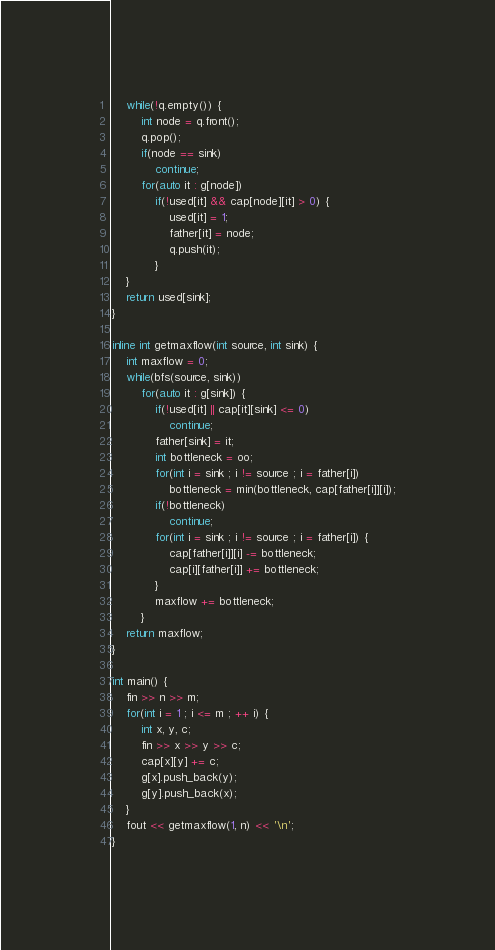Convert code to text. <code><loc_0><loc_0><loc_500><loc_500><_C++_>	while(!q.empty()) {
		int node = q.front();
		q.pop();
		if(node == sink)
			continue;
		for(auto it : g[node])
			if(!used[it] && cap[node][it] > 0) {
				used[it] = 1;
				father[it] = node;
				q.push(it);
			}
	}
	return used[sink];
}

inline int getmaxflow(int source, int sink) {
	int maxflow = 0;
	while(bfs(source, sink))
		for(auto it : g[sink]) {
			if(!used[it] || cap[it][sink] <= 0)
				continue;
			father[sink] = it;
			int bottleneck = oo;
			for(int i = sink ; i != source ; i = father[i])
				bottleneck = min(bottleneck, cap[father[i]][i]);
			if(!bottleneck)
				continue;
			for(int i = sink ; i != source ; i = father[i]) {
				cap[father[i]][i] -= bottleneck;
				cap[i][father[i]] += bottleneck;
			}
			maxflow += bottleneck;
		}
	return maxflow;
}

int main() {
	fin >> n >> m;
	for(int i = 1 ; i <= m ; ++ i) {
		int x, y, c;
		fin >> x >> y >> c;
		cap[x][y] += c;
		g[x].push_back(y);
		g[y].push_back(x);
	}
	fout << getmaxflow(1, n) << '\n';
}
</code> 